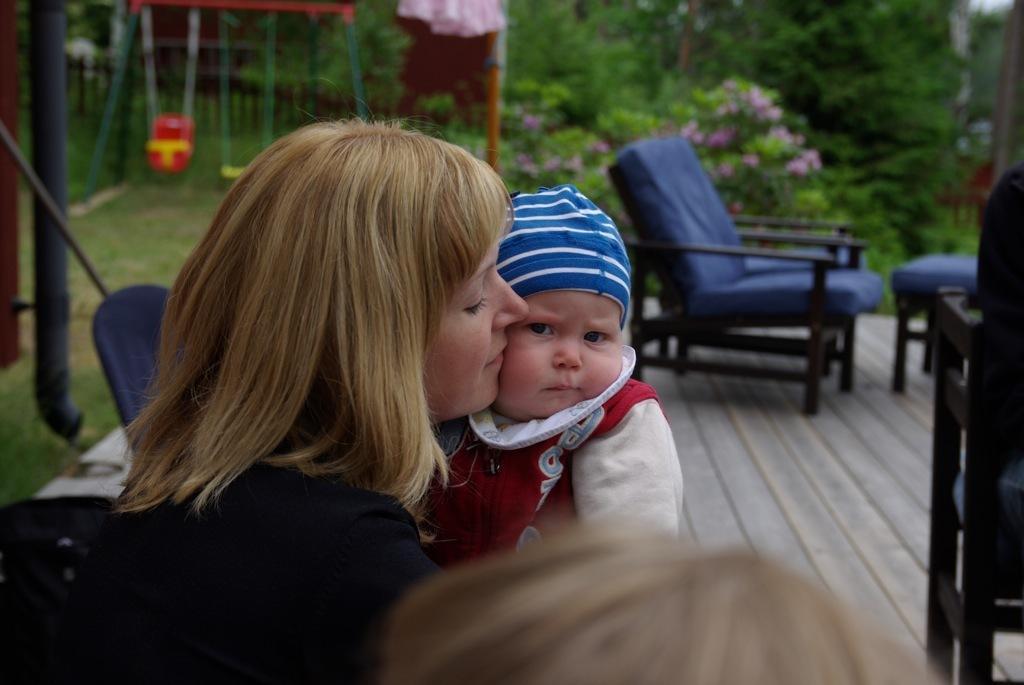Describe this image in one or two sentences. In this image I can see a woman and a child. In the background I can see few chairs and number of trees. 